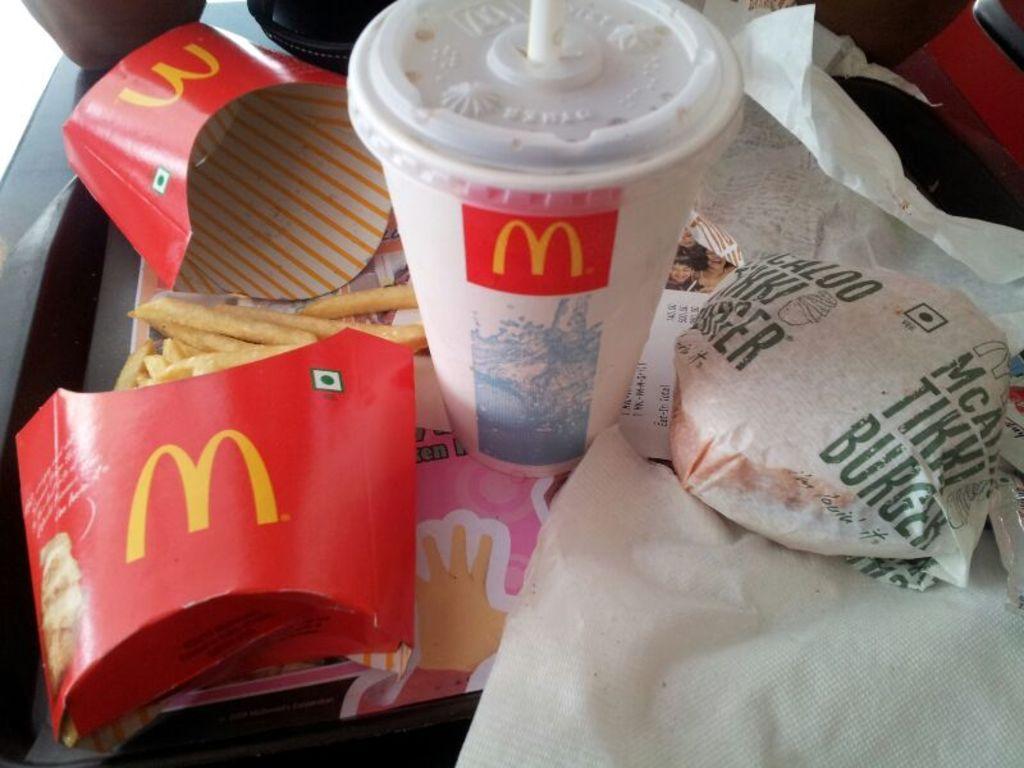Describe this image in one or two sentences. In the center of this picture we can see a glass and the french fries and we can see the text on the papers and pictures on the papers and we can see some food items and some other objects. 